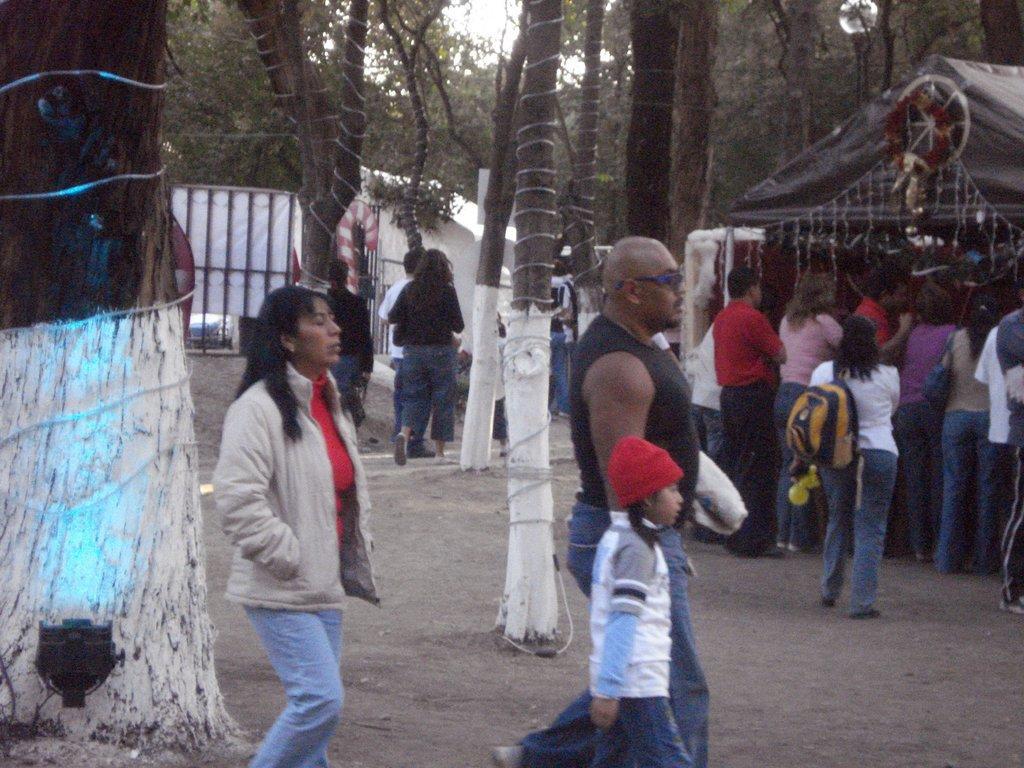In one or two sentences, can you explain what this image depicts? As we can see in the image there are few people here and there, wall, gate and trees. On the top there is a sky. 